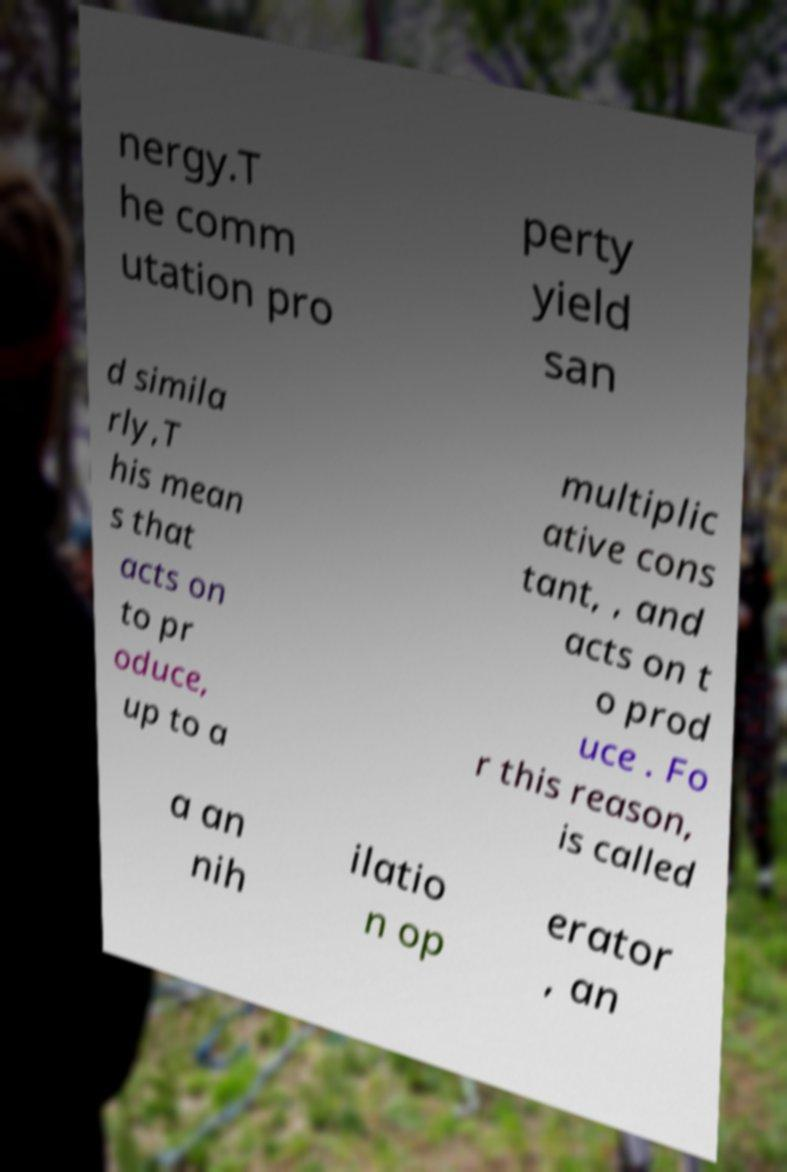Can you read and provide the text displayed in the image?This photo seems to have some interesting text. Can you extract and type it out for me? nergy.T he comm utation pro perty yield san d simila rly,T his mean s that acts on to pr oduce, up to a multiplic ative cons tant, , and acts on t o prod uce . Fo r this reason, is called a an nih ilatio n op erator , an 